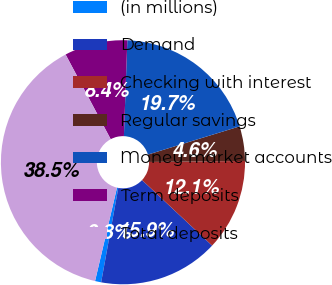Convert chart. <chart><loc_0><loc_0><loc_500><loc_500><pie_chart><fcel>(in millions)<fcel>Demand<fcel>Checking with interest<fcel>Regular savings<fcel>Money market accounts<fcel>Term deposits<fcel>Total deposits<nl><fcel>0.81%<fcel>15.9%<fcel>12.13%<fcel>4.58%<fcel>19.68%<fcel>8.36%<fcel>38.54%<nl></chart> 